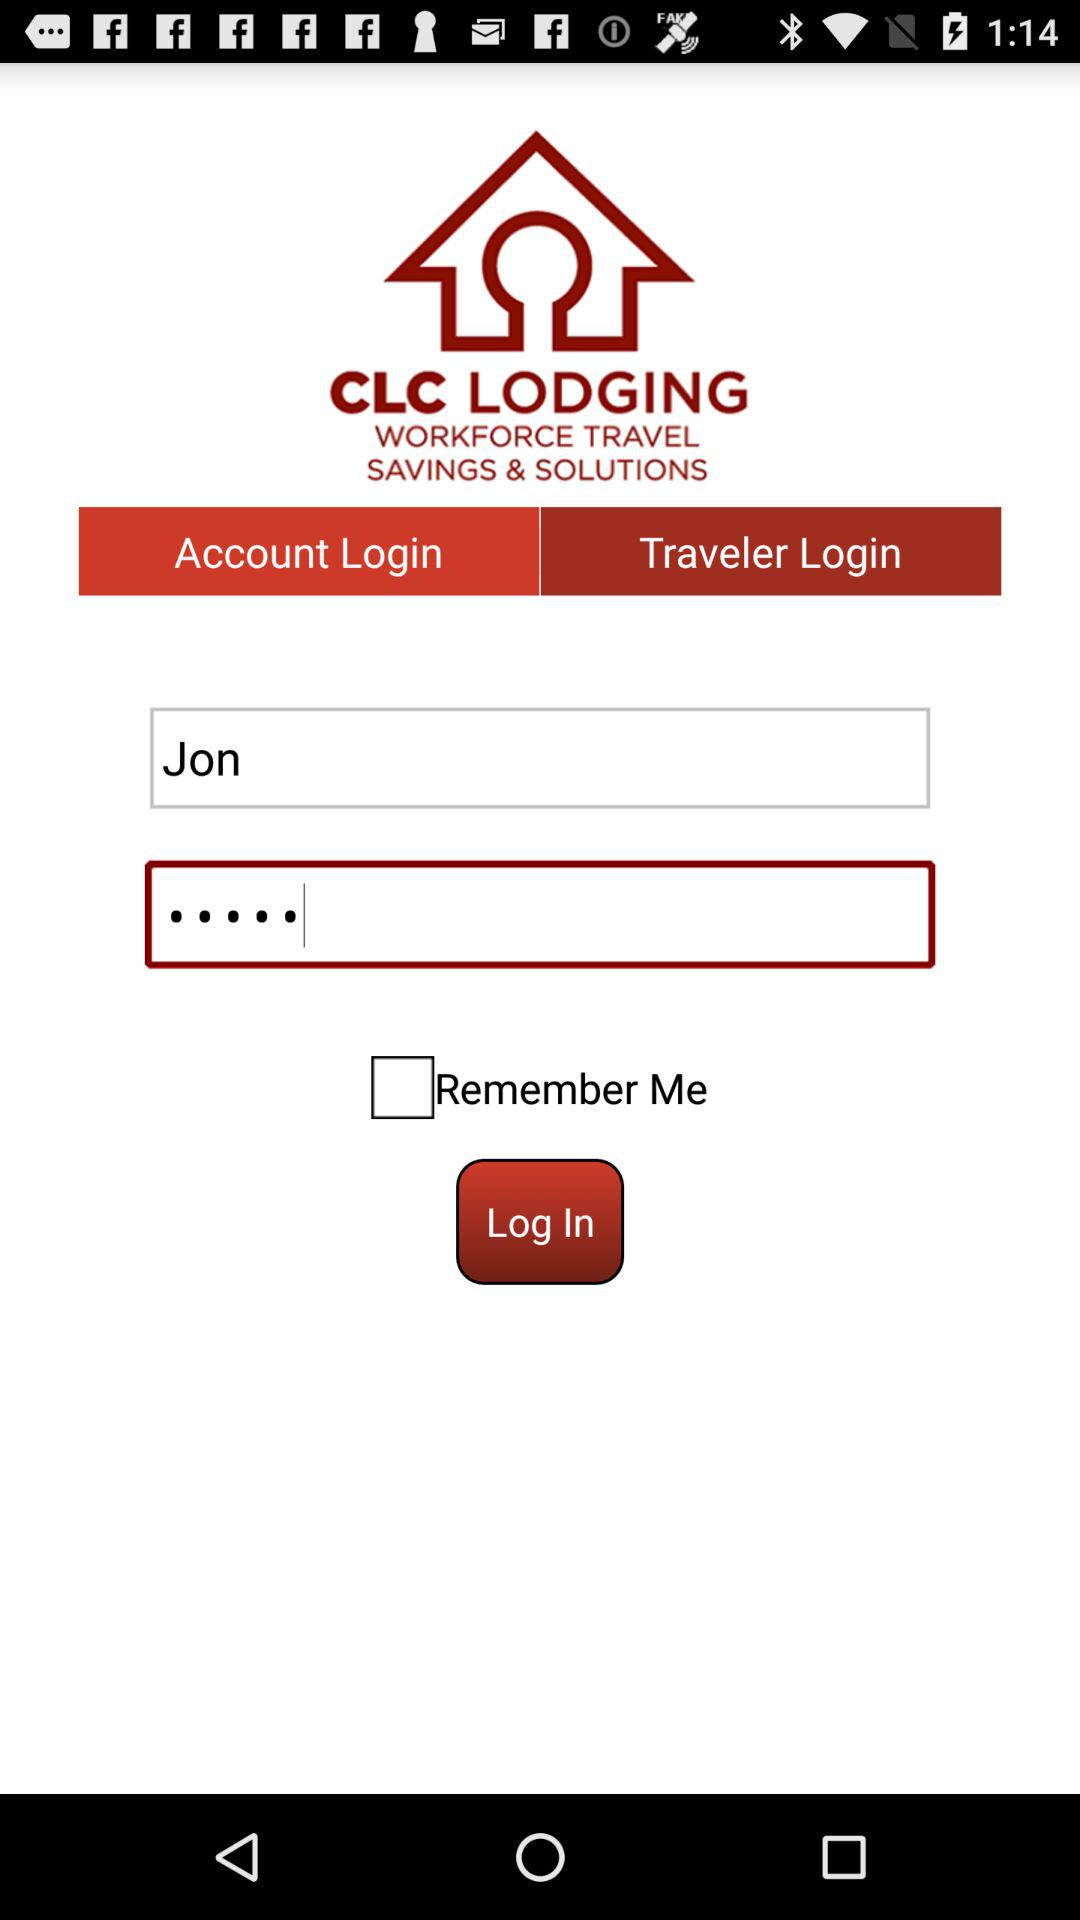What is the mentioned name? The mentioned name is Jon. 